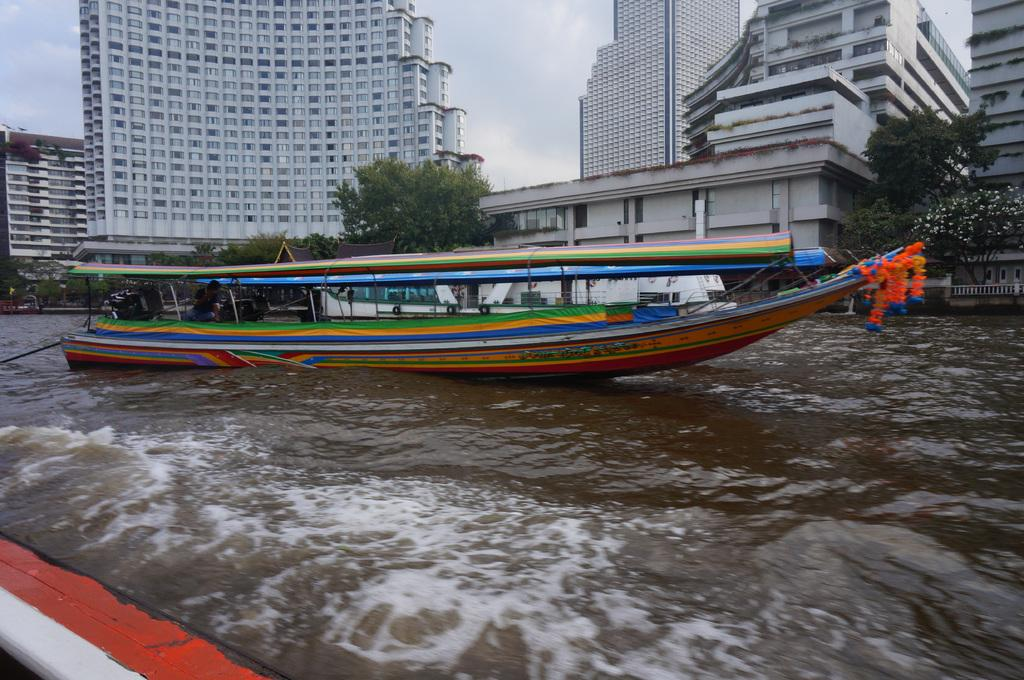What is the main subject of the image? The main subject of the image is a boat. What is the boat doing in the image? The boat is floating in the water. What can be seen in the background of the image? There are trees, buildings, and a cloudy sky in the background of the image. How many zips are on the boat in the image? There are no zips present on the boat in the image. What type of lip can be seen on the boat in the image? There is no lip present on the boat in the image. 